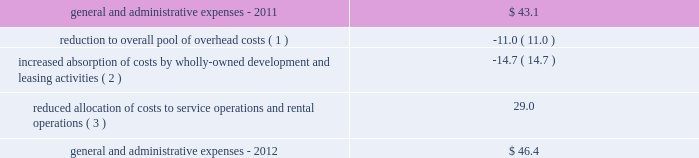29 annual report 2012 duke realty corporation | | those indirect costs not allocated to or absorbed by these operations are charged to general and administrative expenses .
We regularly review our total overhead cost structure relative to our leasing , development and construction volume and adjust the level of total overhead , generally through changes in our level of staffing in various functional departments , as necessary in order to control overall general and administrative expense .
General and administrative expenses increased from $ 43.1 million in 2011 to $ 46.4 million in 2012 .
The table sets forth the factors that led to the increase in general and administrative expenses from 2011 to 2012 ( in millions ) : .
( 1 ) we reduced our total pool of overhead costs , through staff reductions and other measures , as the result of changes in our product mix and anticipated future levels of third-party construction , leasing , management and other operational activities .
( 2 ) we increased our focus on development of wholly-owned properties , and also significantly increased our leasing activity during 2012 , which resulted in an increased absorption of overhead costs .
We capitalized $ 30.4 million and $ 20.0 million of our total overhead costs to leasing and development , respectively , for consolidated properties during 2012 , compared to capitalizing $ 25.3 million and $ 10.4 million of such costs , respectively , for 2011 .
Combined overhead costs capitalized to leasing and development totaled 31.1% ( 31.1 % ) and 20.6% ( 20.6 % ) of our overall pool of overhead costs for 2012 and 2011 , respectively .
( 3 ) the reduction in the allocation of overhead costs to service operations and rental operations resulted from reduced volumes of third-party construction projects as well as due to reducing our overall investment in office properties , which are more management intensive .
Interest expense interest expense allocable to continuing operations increased from $ 220.5 million in 2011 to $ 245.2 million in 2012 .
We had $ 47.4 million of interest expense allocated to discontinued operations in 2011 , associated with the properties that were disposed of during 2011 , compared to the allocation of only $ 3.1 million of interest expense to discontinued operations for 2012 .
Total interest expense , combined for continuing and discontinued operations , decreased from $ 267.8 million in 2011 to $ 248.3 million in 2012 .
The reduction in total interest expense was primarily the result of a lower weighted average borrowing rate in 2012 , due to refinancing some higher rate bonds in 2011 and 2012 , as well as a slight decrease in our average level of borrowings compared to 2011 .
Also , due to an increase in properties under development from 2011 , which met the criteria for capitalization of interest and were financed in part by common equity issuances during 2012 , a $ 5.0 million increase in capitalized interest also contributed to the decrease in total interest expense in 2012 .
Acquisition-related activity during 2012 , we recognized approximately $ 4.2 million in acquisition costs , compared to $ 2.3 million of such costs in 2011 .
The increase from 2011 to 2012 is the result of acquiring a higher volume of medical office properties , where a higher level of acquisition costs are incurred than other property types , in 2012 .
During 2011 , we also recognized a $ 1.1 million gain related to the acquisition of a building from one of our 50%-owned unconsolidated joint ventures .
Discontinued operations subject to certain criteria , the results of operations for properties sold during the year to unrelated parties , or classified as held-for-sale at the end of the period , are required to be classified as discontinued operations .
The property specific components of earnings that are classified as discontinued operations include rental revenues , rental expenses , real estate taxes , allocated interest expense and depreciation expense , as well as the net gain or loss on the disposition of properties .
The operations of 150 buildings are currently classified as discontinued operations .
These 150 buildings consist of 114 office , 30 industrial , four retail , and two medical office properties .
As a result , we classified operating losses , before gain on sales , of $ 1.5 million , $ 1.8 million and $ 7.1 million in discontinued operations for the years ended december 31 , 2012 , 2011 and 2010 , respectively .
Of these properties , 28 were sold during 2012 , 101 properties were sold during 2011 and 19 properties were sold during 2010 .
The gains on disposal of these properties of $ 13.5 million , $ 100.9 million and $ 33.1 million for the years ended december 31 , 2012 , 2011 and .
What was the percentage change in the general and administrative expenses in 2012? 
Computations: ((46.4 - 43.1) / 43.1)
Answer: 0.07657. 